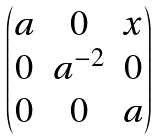Convert formula to latex. <formula><loc_0><loc_0><loc_500><loc_500>\begin{pmatrix} a & 0 & x \\ 0 & a ^ { - 2 } & 0 \\ 0 & 0 & a \end{pmatrix}</formula> 